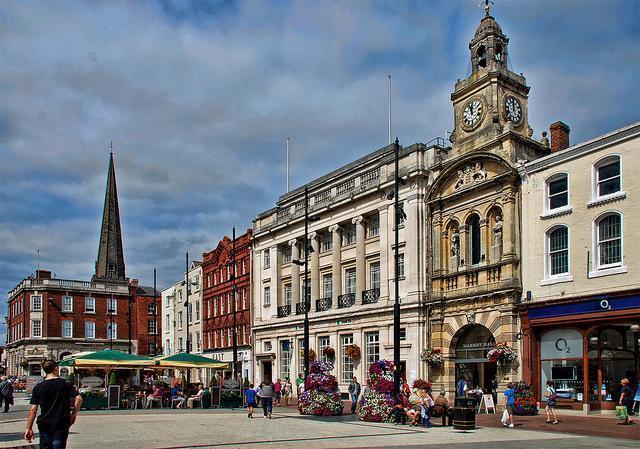How many people are in the photo?
Give a very brief answer. 2. 